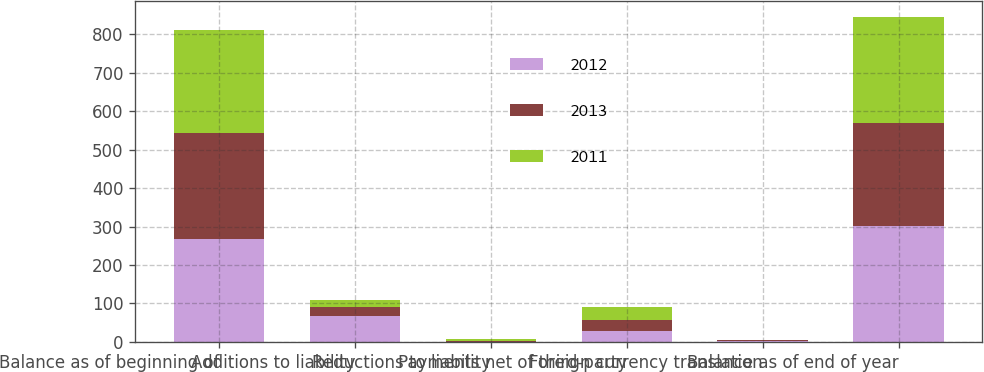Convert chart to OTSL. <chart><loc_0><loc_0><loc_500><loc_500><stacked_bar_chart><ecel><fcel>Balance as of beginning of<fcel>Additions to liability<fcel>Reductions to liability<fcel>Payments net of third-party<fcel>Foreign currency translation<fcel>Balance as of end of year<nl><fcel>2012<fcel>269<fcel>67<fcel>1<fcel>28<fcel>2<fcel>301<nl><fcel>2013<fcel>274<fcel>23<fcel>1<fcel>29<fcel>2<fcel>269<nl><fcel>2011<fcel>268<fcel>18<fcel>5<fcel>35<fcel>2<fcel>274<nl></chart> 